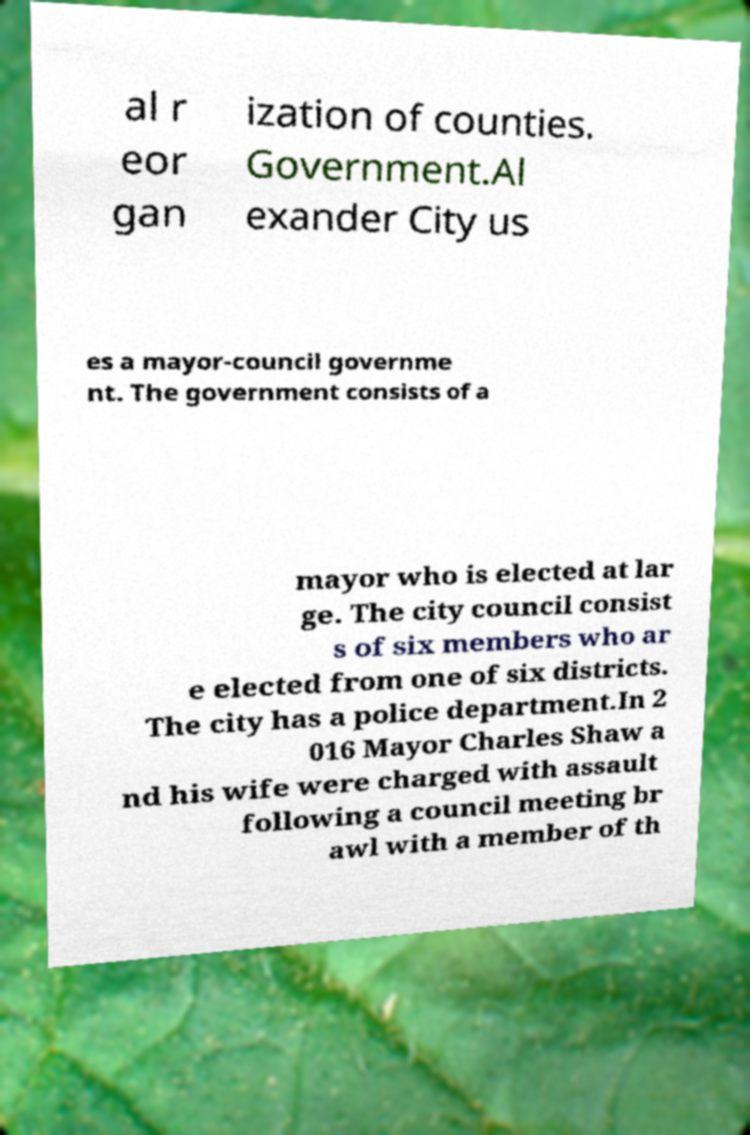What messages or text are displayed in this image? I need them in a readable, typed format. al r eor gan ization of counties. Government.Al exander City us es a mayor-council governme nt. The government consists of a mayor who is elected at lar ge. The city council consist s of six members who ar e elected from one of six districts. The city has a police department.In 2 016 Mayor Charles Shaw a nd his wife were charged with assault following a council meeting br awl with a member of th 